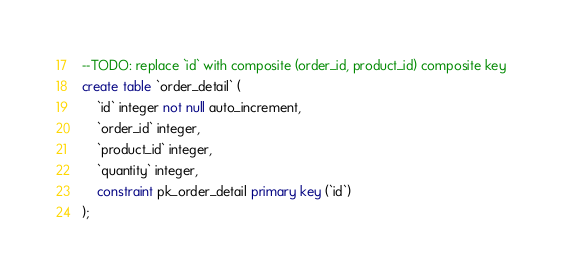Convert code to text. <code><loc_0><loc_0><loc_500><loc_500><_SQL_>--TODO: replace `id` with composite (order_id, product_id) composite key
create table `order_detail` (
    `id` integer not null auto_increment,
    `order_id` integer,
    `product_id` integer,
    `quantity` integer,
    constraint pk_order_detail primary key (`id`)
);
</code> 